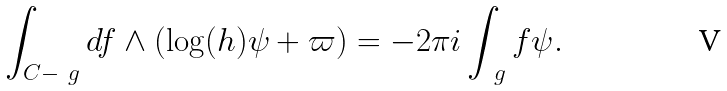Convert formula to latex. <formula><loc_0><loc_0><loc_500><loc_500>\int _ { C - \ g } d f \wedge ( \log ( h ) \psi + \varpi ) = - 2 \pi i \int _ { \ g } f \psi .</formula> 